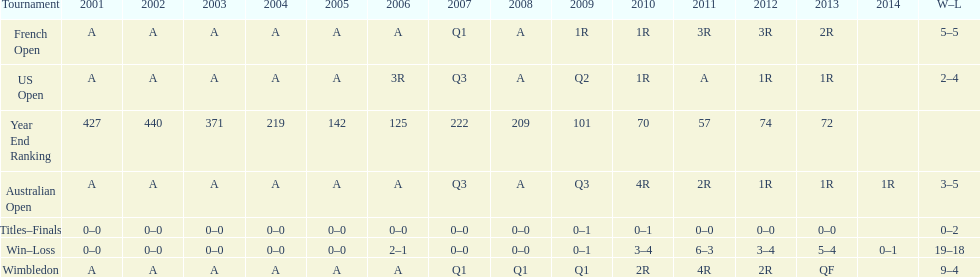In what year was the best year end ranking achieved? 2011. 